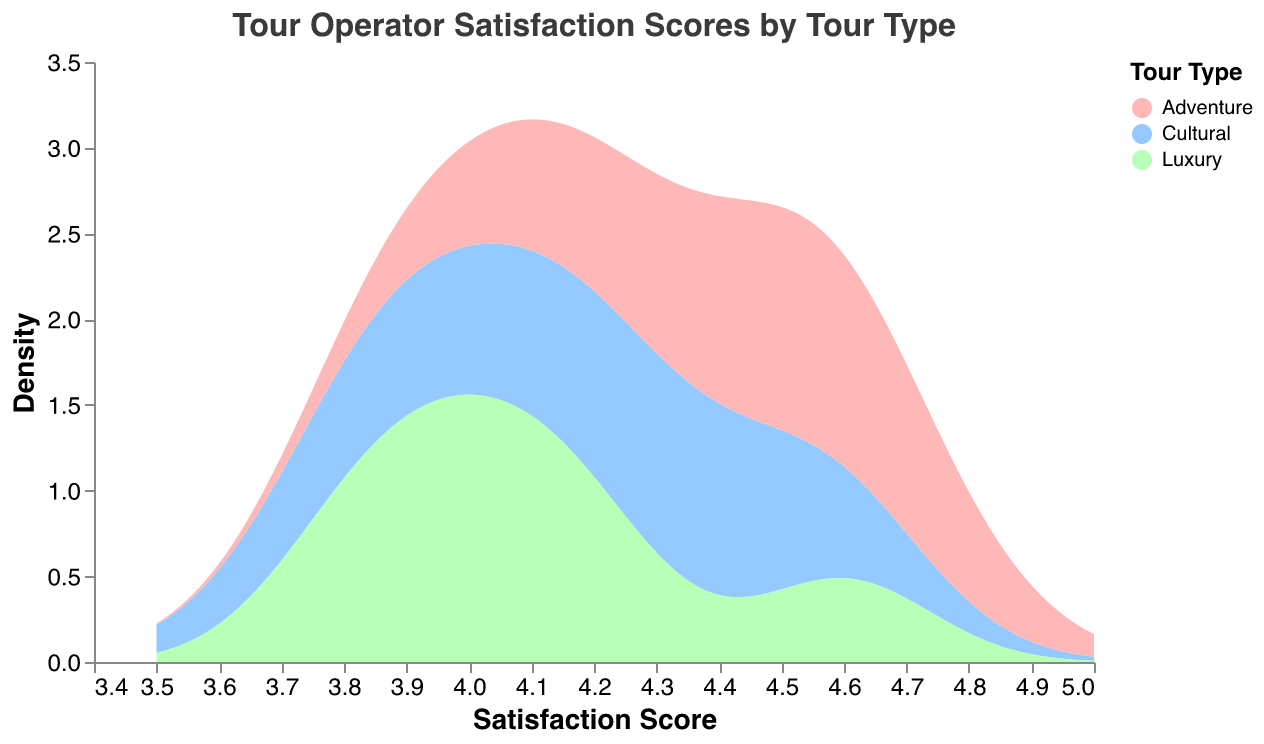What is the title of the figure? The title is displayed prominently at the top of the chart. Reading the title tells us what the figure is about.
Answer: Tour Operator Satisfaction Scores by Tour Type What are the axis labels? The x-axis is labeled "Satisfaction Score" and the y-axis is labeled "Density". These labels tell us what the axes represent in the figure.
Answer: Satisfaction Score, Density What colors represent the different types of tours? The color legend on the right side of the chart shows that cultural tours are represented in red, adventure tours in blue, and luxury tours in green.
Answer: Cultural: red, Adventure: blue, Luxury: green Which type of tour has the highest density peak? By inspecting the height of the density curves, we can see which one reaches the highest point. The adventure tours' density peak is higher than others.
Answer: Adventure tours How do the satisfaction scores vary for cultural tours across different operators? We look at the distribution and density of the scores for just cultural tours to see their spread. The scores range from around 3.8 to 4.5 with varying densities.
Answer: 3.8 to 4.5 Which type of tour has the least variation in satisfaction scores? By observing the spread of the density curves, we can determine which type has a tighter and less variable distribution. Adventure tours have a narrower and more consistent range of scores.
Answer: Adventure tours Between cultural and luxury tours, which one shows higher density at a satisfaction score of 4.1? We compare the heights of the density curves for cultural and luxury tours at the score of 4.1. The density for cultural tours at 4.1 is higher than for luxury tours.
Answer: Cultural tours What is the rough range of satisfaction scores for luxury tours? We identify the spread of the density curve for luxury tours on the x-axis to determine the range. The scores generally range from 3.8 to 4.6.
Answer: 3.8 to 4.6 Do adventure tours or cultural tours have a broader range of satisfaction scores? By comparing the spread of the density curves for both types of tours, we see that cultural tours have a broader range of scores.
Answer: Cultural tours Which type of tour shows a significant peak around a satisfaction score of 4.5? We look for the density curve that shows a noticeable peak around the score of 4.5. Adventure tours have a significant peak around 4.5.
Answer: Adventure tours 